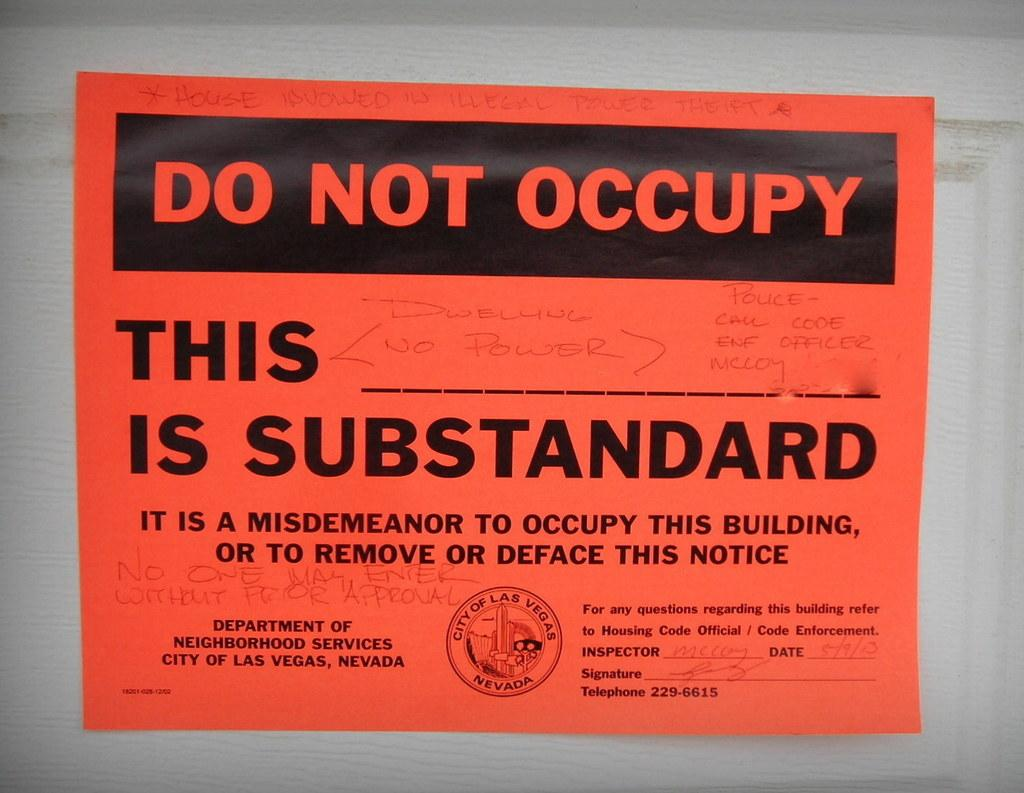<image>
Offer a succinct explanation of the picture presented. Red sign that tells people "Do Not Occupy". 